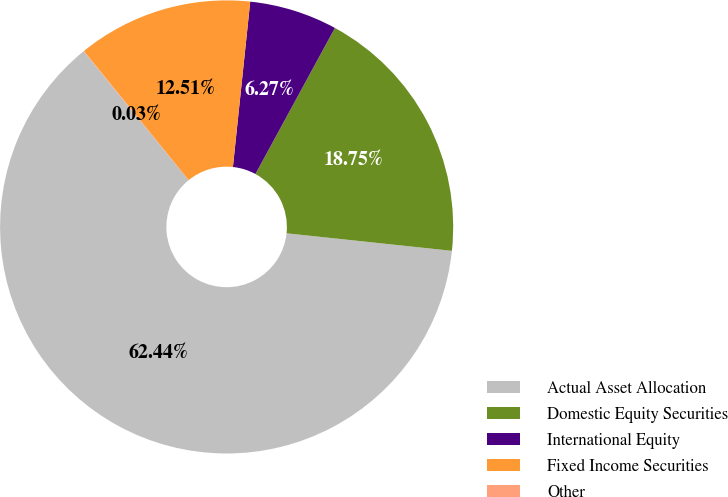Convert chart to OTSL. <chart><loc_0><loc_0><loc_500><loc_500><pie_chart><fcel>Actual Asset Allocation<fcel>Domestic Equity Securities<fcel>International Equity<fcel>Fixed Income Securities<fcel>Other<nl><fcel>62.43%<fcel>18.75%<fcel>6.27%<fcel>12.51%<fcel>0.03%<nl></chart> 